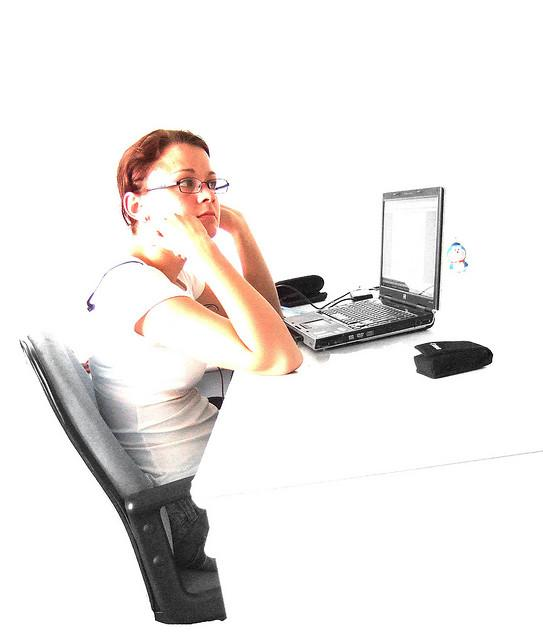Why is the woman sitting down? using laptop 